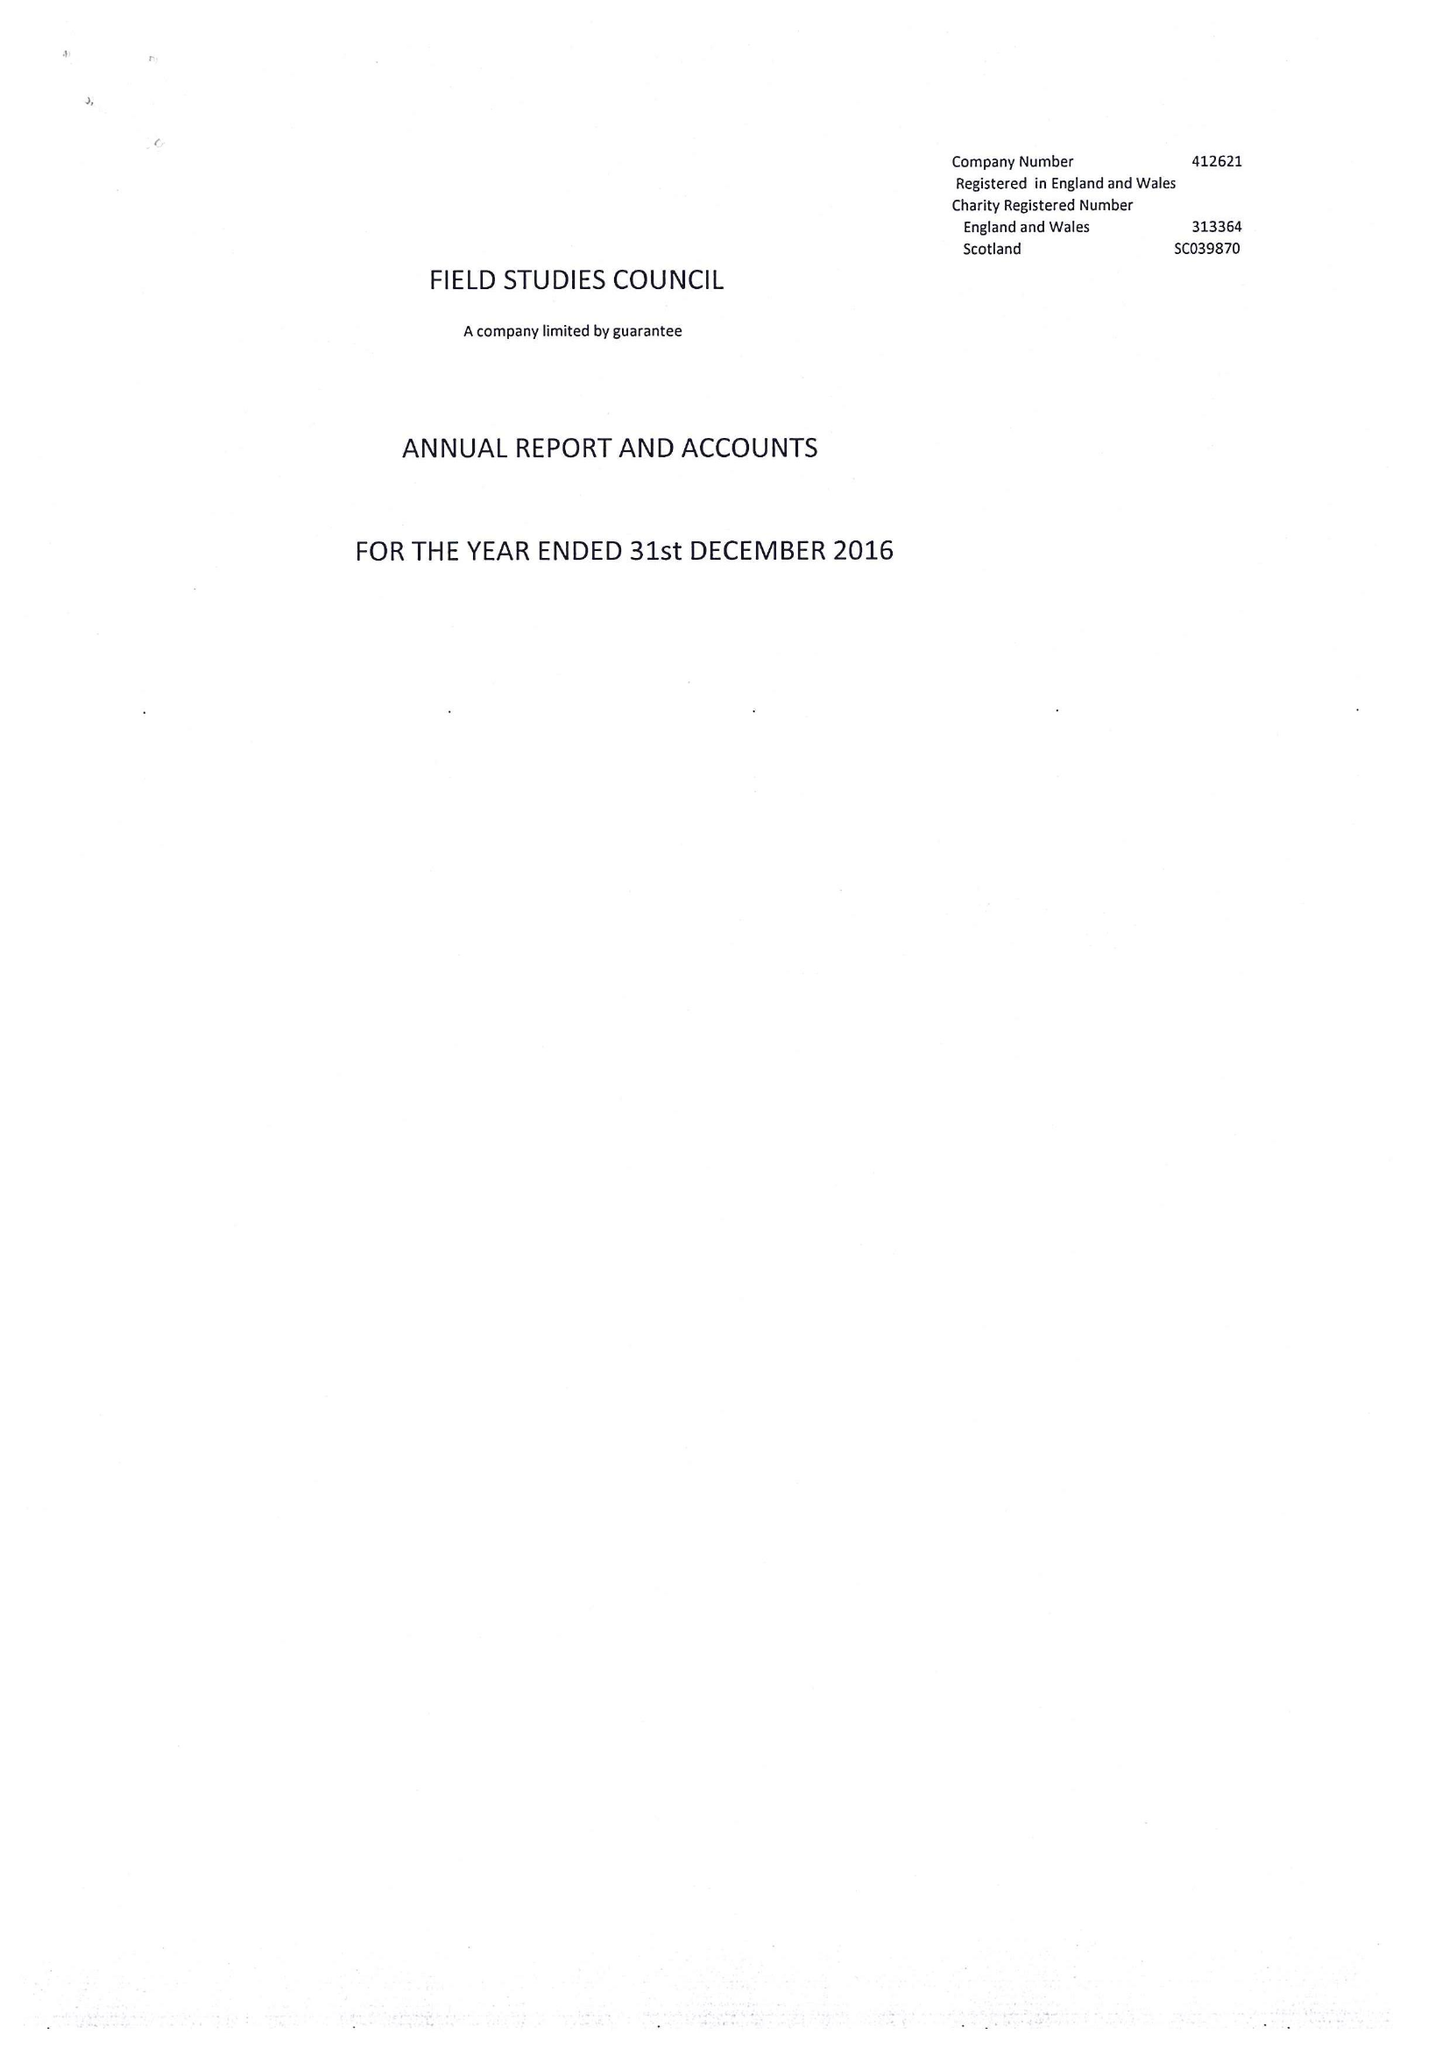What is the value for the address__street_line?
Answer the question using a single word or phrase. None 